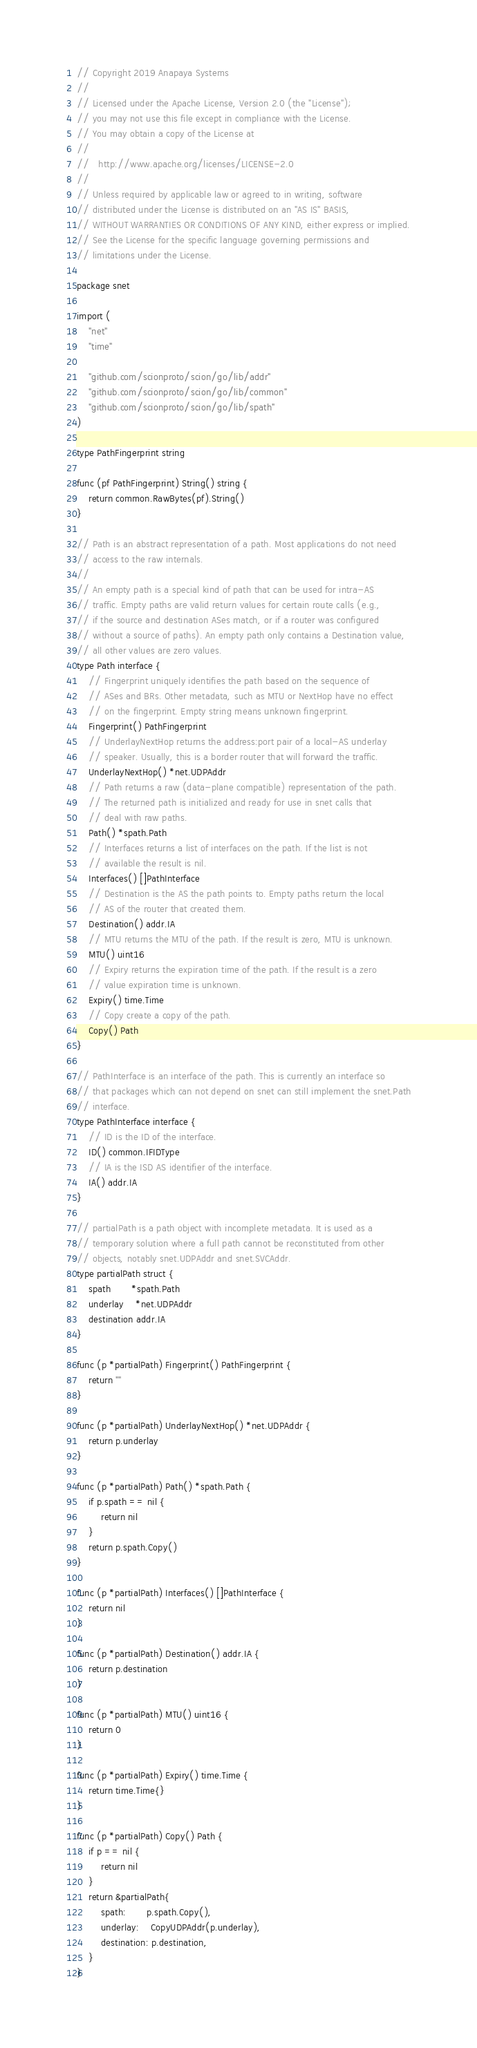Convert code to text. <code><loc_0><loc_0><loc_500><loc_500><_Go_>// Copyright 2019 Anapaya Systems
//
// Licensed under the Apache License, Version 2.0 (the "License");
// you may not use this file except in compliance with the License.
// You may obtain a copy of the License at
//
//   http://www.apache.org/licenses/LICENSE-2.0
//
// Unless required by applicable law or agreed to in writing, software
// distributed under the License is distributed on an "AS IS" BASIS,
// WITHOUT WARRANTIES OR CONDITIONS OF ANY KIND, either express or implied.
// See the License for the specific language governing permissions and
// limitations under the License.

package snet

import (
	"net"
	"time"

	"github.com/scionproto/scion/go/lib/addr"
	"github.com/scionproto/scion/go/lib/common"
	"github.com/scionproto/scion/go/lib/spath"
)

type PathFingerprint string

func (pf PathFingerprint) String() string {
	return common.RawBytes(pf).String()
}

// Path is an abstract representation of a path. Most applications do not need
// access to the raw internals.
//
// An empty path is a special kind of path that can be used for intra-AS
// traffic. Empty paths are valid return values for certain route calls (e.g.,
// if the source and destination ASes match, or if a router was configured
// without a source of paths). An empty path only contains a Destination value,
// all other values are zero values.
type Path interface {
	// Fingerprint uniquely identifies the path based on the sequence of
	// ASes and BRs. Other metadata, such as MTU or NextHop have no effect
	// on the fingerprint. Empty string means unknown fingerprint.
	Fingerprint() PathFingerprint
	// UnderlayNextHop returns the address:port pair of a local-AS underlay
	// speaker. Usually, this is a border router that will forward the traffic.
	UnderlayNextHop() *net.UDPAddr
	// Path returns a raw (data-plane compatible) representation of the path.
	// The returned path is initialized and ready for use in snet calls that
	// deal with raw paths.
	Path() *spath.Path
	// Interfaces returns a list of interfaces on the path. If the list is not
	// available the result is nil.
	Interfaces() []PathInterface
	// Destination is the AS the path points to. Empty paths return the local
	// AS of the router that created them.
	Destination() addr.IA
	// MTU returns the MTU of the path. If the result is zero, MTU is unknown.
	MTU() uint16
	// Expiry returns the expiration time of the path. If the result is a zero
	// value expiration time is unknown.
	Expiry() time.Time
	// Copy create a copy of the path.
	Copy() Path
}

// PathInterface is an interface of the path. This is currently an interface so
// that packages which can not depend on snet can still implement the snet.Path
// interface.
type PathInterface interface {
	// ID is the ID of the interface.
	ID() common.IFIDType
	// IA is the ISD AS identifier of the interface.
	IA() addr.IA
}

// partialPath is a path object with incomplete metadata. It is used as a
// temporary solution where a full path cannot be reconstituted from other
// objects, notably snet.UDPAddr and snet.SVCAddr.
type partialPath struct {
	spath       *spath.Path
	underlay    *net.UDPAddr
	destination addr.IA
}

func (p *partialPath) Fingerprint() PathFingerprint {
	return ""
}

func (p *partialPath) UnderlayNextHop() *net.UDPAddr {
	return p.underlay
}

func (p *partialPath) Path() *spath.Path {
	if p.spath == nil {
		return nil
	}
	return p.spath.Copy()
}

func (p *partialPath) Interfaces() []PathInterface {
	return nil
}

func (p *partialPath) Destination() addr.IA {
	return p.destination
}

func (p *partialPath) MTU() uint16 {
	return 0
}

func (p *partialPath) Expiry() time.Time {
	return time.Time{}
}

func (p *partialPath) Copy() Path {
	if p == nil {
		return nil
	}
	return &partialPath{
		spath:       p.spath.Copy(),
		underlay:    CopyUDPAddr(p.underlay),
		destination: p.destination,
	}
}
</code> 